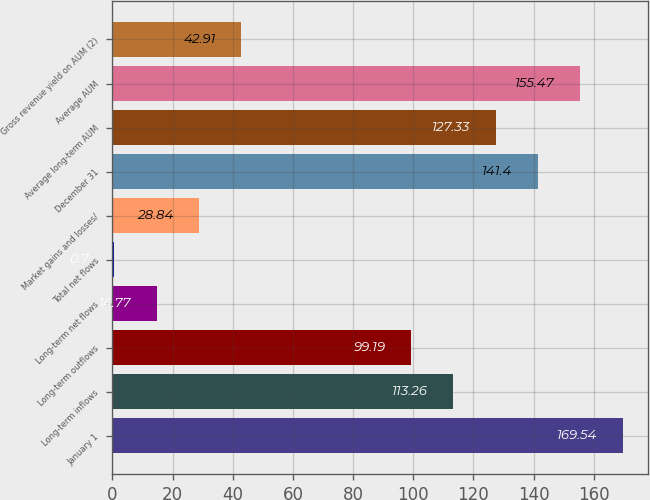Convert chart. <chart><loc_0><loc_0><loc_500><loc_500><bar_chart><fcel>January 1<fcel>Long-term inflows<fcel>Long-term outflows<fcel>Long-term net flows<fcel>Total net flows<fcel>Market gains and losses/<fcel>December 31<fcel>Average long-term AUM<fcel>Average AUM<fcel>Gross revenue yield on AUM (2)<nl><fcel>169.54<fcel>113.26<fcel>99.19<fcel>14.77<fcel>0.7<fcel>28.84<fcel>141.4<fcel>127.33<fcel>155.47<fcel>42.91<nl></chart> 